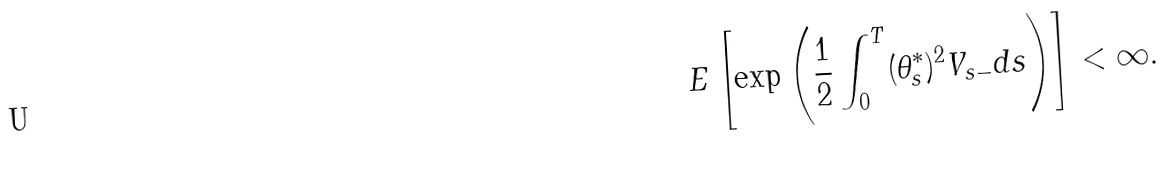Convert formula to latex. <formula><loc_0><loc_0><loc_500><loc_500>E \left [ \exp \left ( \frac { 1 } { 2 } \int _ { 0 } ^ { T } ( \theta ^ { * } _ { s } ) ^ { 2 } V _ { s - } d s \right ) \right ] < \infty .</formula> 